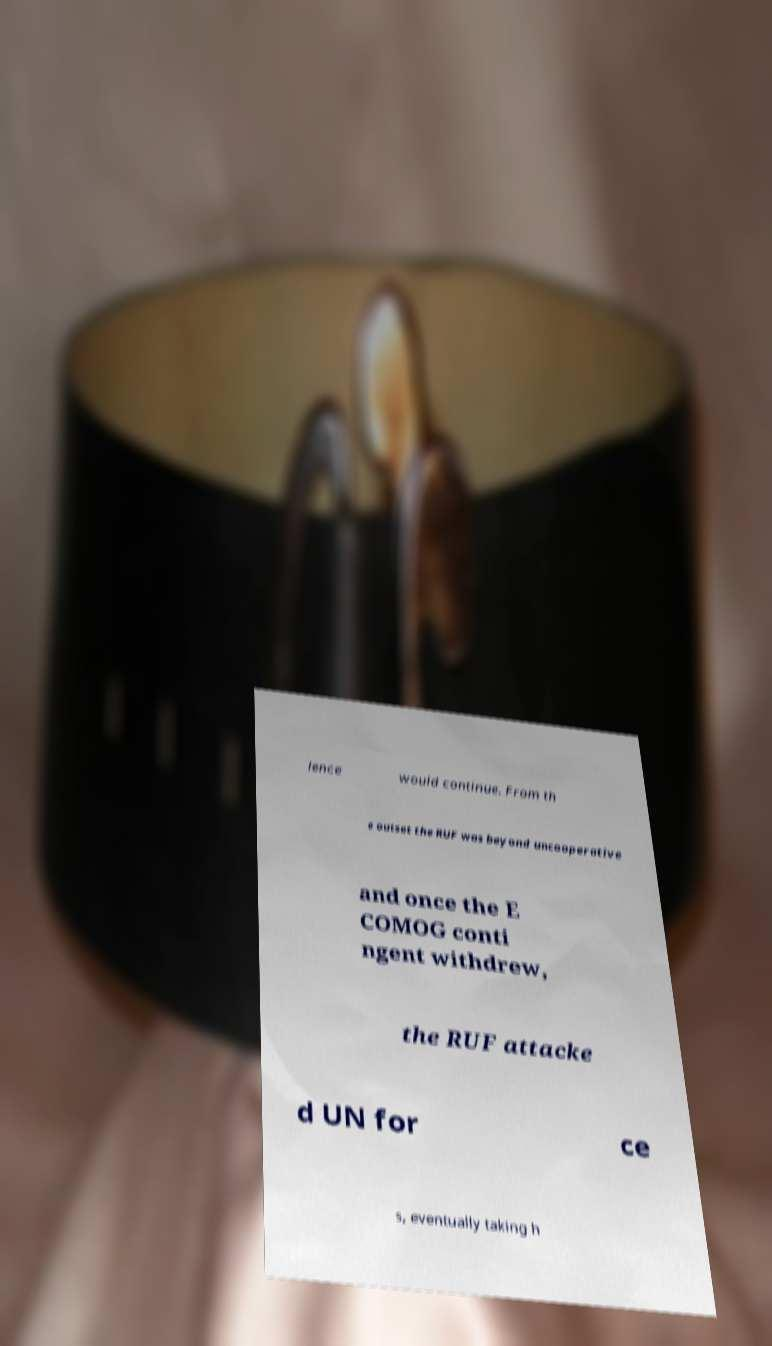There's text embedded in this image that I need extracted. Can you transcribe it verbatim? lence would continue. From th e outset the RUF was beyond uncooperative and once the E COMOG conti ngent withdrew, the RUF attacke d UN for ce s, eventually taking h 